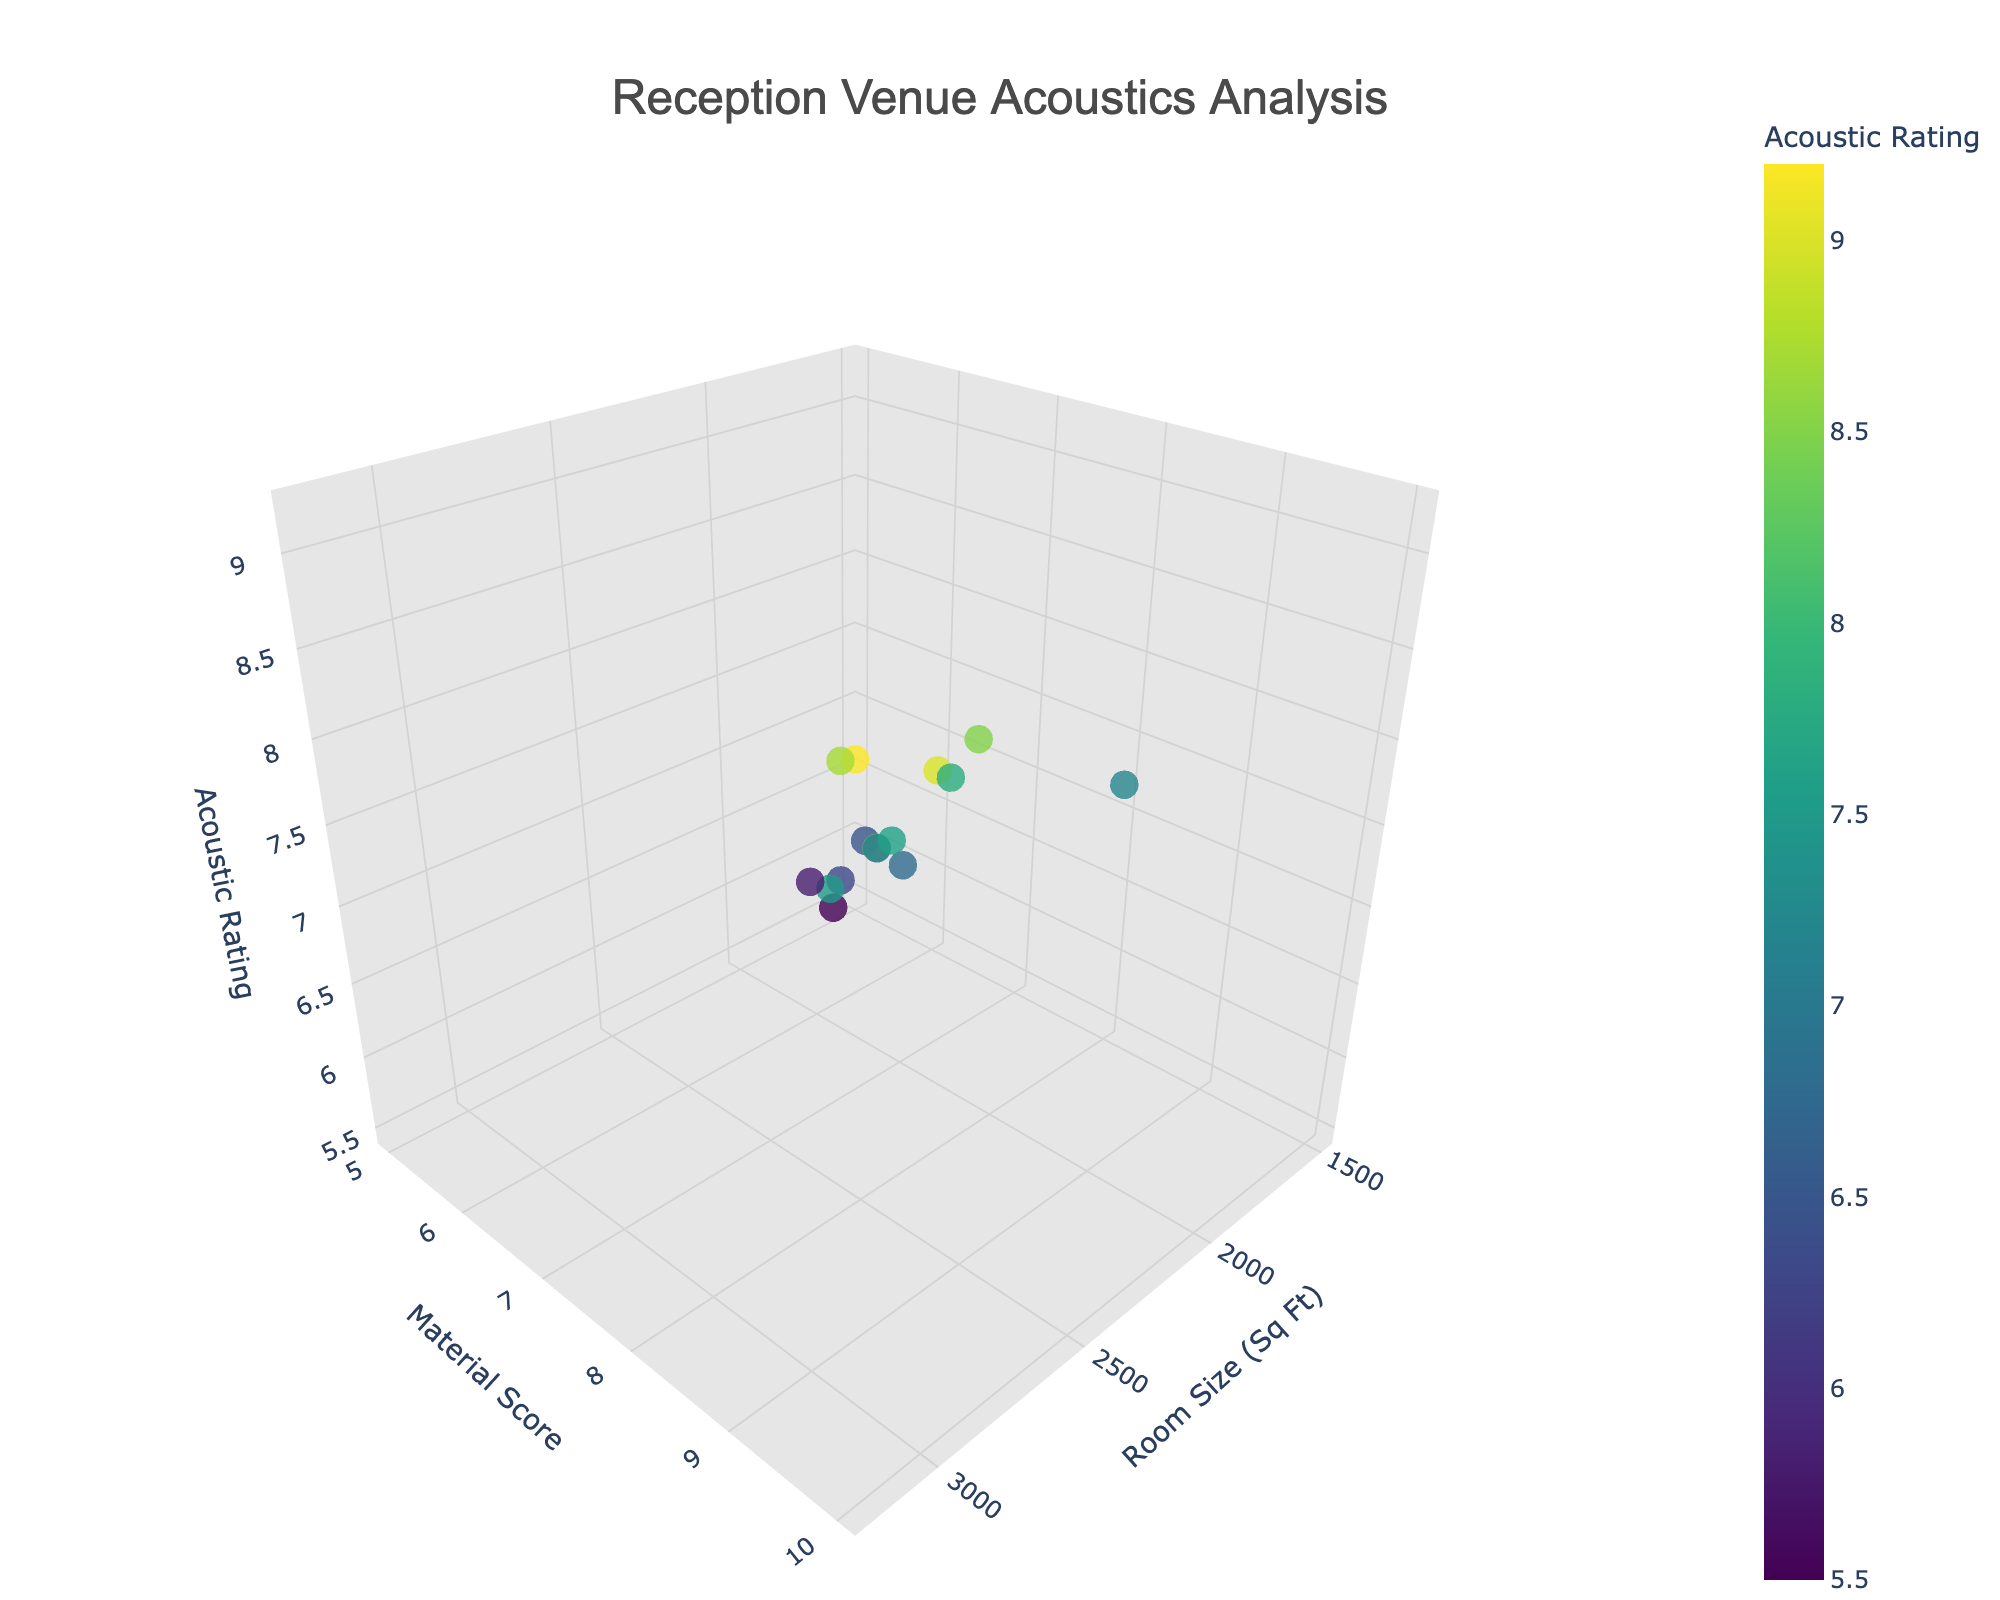What's the title of the figure? The title is typically prominently displayed at the top of the figure, often in a larger font size.
Answer: Reception Venue Acoustics Analysis How many data points are there in the plot? Data points can be counted by identifying individual markers in the 3D scatter plot.
Answer: 15 Which room shape has the highest acoustic rating? The highest acoustic rating can be determined by identifying the marker with the highest position along the z-axis and then checking the text label for the room shape.
Answer: Rectangular What is the room size for the venue with an acoustic rating of 8.7? Locate the point on the z-axis where the acoustic rating is 8.7 and trace it back to the x-axis for the room size.
Answer: 2900 Sq Ft Which has a higher acoustic rating, the L-Shaped room with a material score of 7 or the square room with a material score of 8? Compare the z-axis values (acoustic ratings) for both specified conditions.
Answer: Square room with material score of 8 What is the average acoustic rating for rectangular rooms? Find all the points labeled as Rectangular, sum their acoustic ratings, and divide by the number of these points.
Answer: (7.2 + 7.0 + 9.0 + 9.2) / 4 = 8.1 Which room size has the lowest material score, and what is the acoustic rating for that room? Identify the point with the lowest y-axis value (material score) and check its room size and acoustic rating.
Answer: 1600 Sq Ft, Acoustic Rating: 5.5 What is the difference in acoustic rating between the largest and smallest rooms? Determine the acoustic ratings of the largest and smallest rooms from the x-axis values and calculate the difference.
Answer: 9.2 - 5.5 = 3.7 What is the relationship between material score and acoustic rating for rooms with sizes above 2500 Sq Ft? Observe the trend or general direction of markers for rooms with x-axis values above 2500 and determine if they generally increase or decrease together.
Answer: Positive correlation Which shape generally provides the best acoustics for a space greater than 2000 Sq Ft? For rooms with sizes greater than 2000 Sq Ft, observe the room shapes and their corresponding acoustic ratings to find the shape with higher ratings most frequently.
Answer: Rectangular 